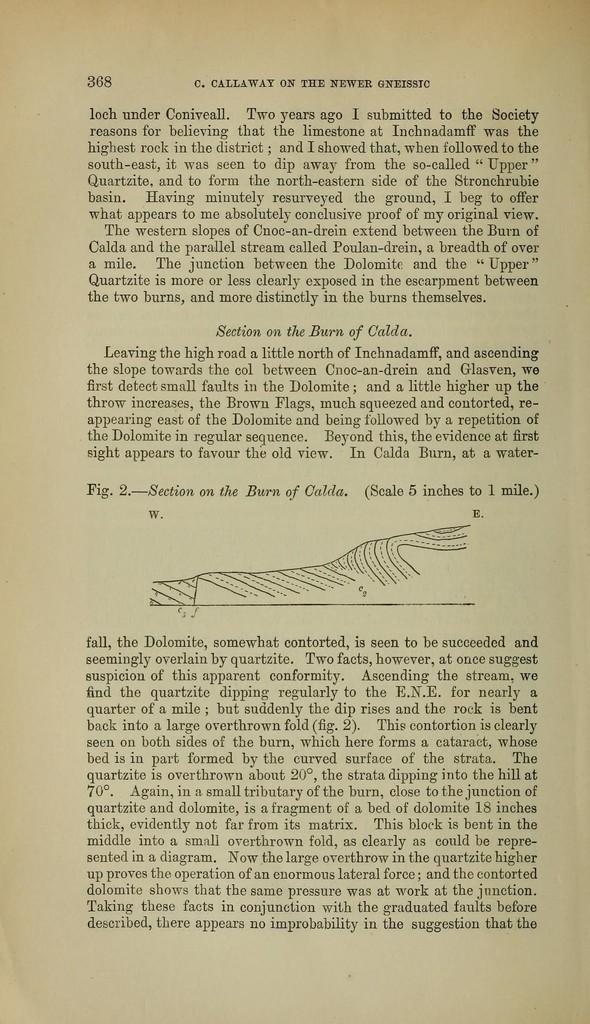What book page is that?
Make the answer very short. 368. What is one of the headings this page has?
Your answer should be compact. Section on the burn of calda. 